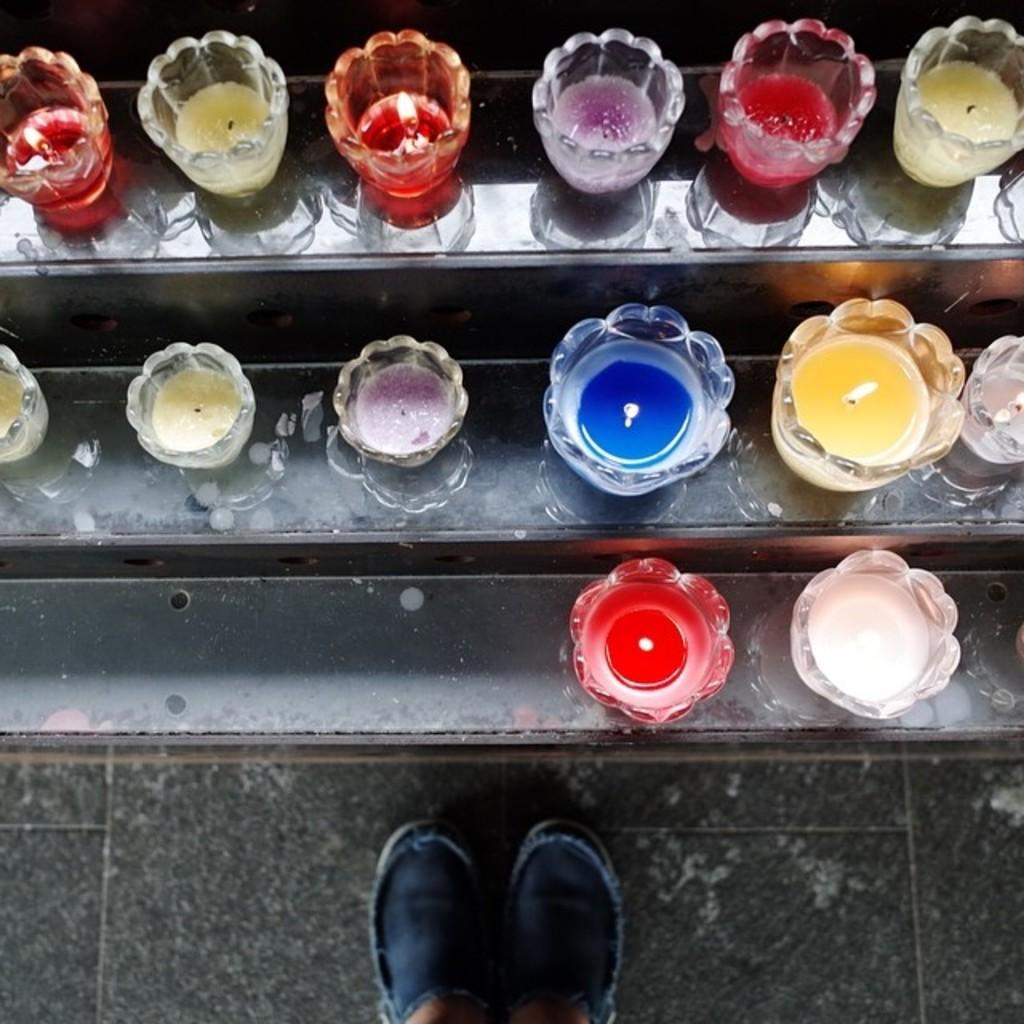What objects can be seen on the shelves in the image? There are candles on the shelves in the image. Can you describe any other elements in the image? The legs of a person are visible in the image. What type of crate is being used to store the wrens in the image? There are no crates or wrens present in the image; it only features candles on shelves and the legs of a person. 